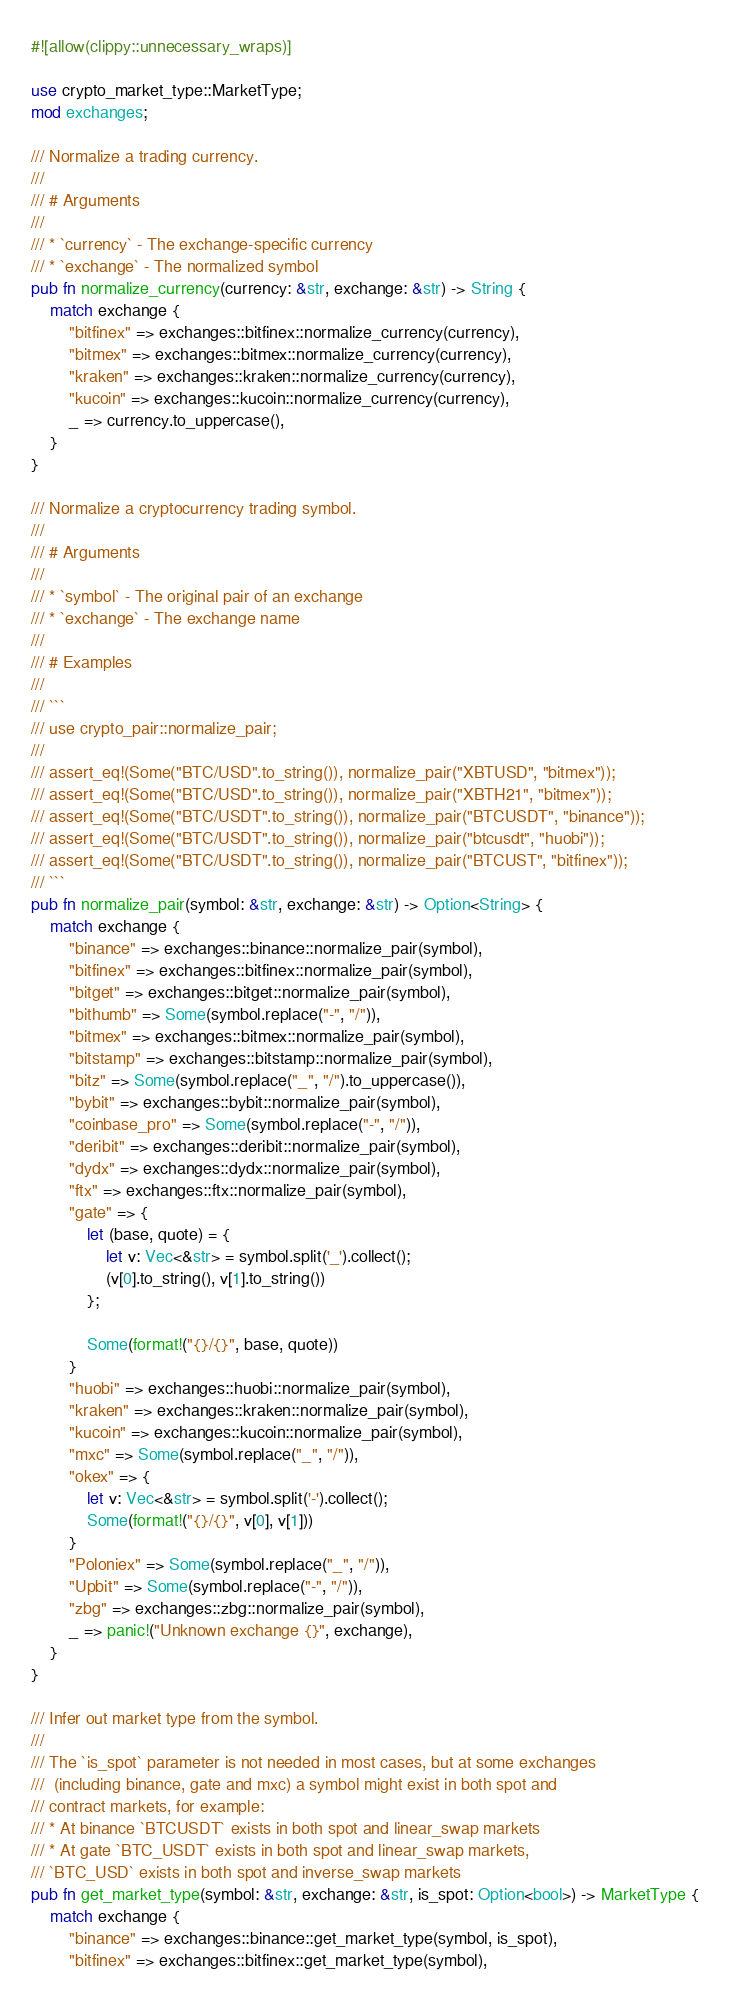<code> <loc_0><loc_0><loc_500><loc_500><_Rust_>#![allow(clippy::unnecessary_wraps)]

use crypto_market_type::MarketType;
mod exchanges;

/// Normalize a trading currency.
///
/// # Arguments
///
/// * `currency` - The exchange-specific currency
/// * `exchange` - The normalized symbol
pub fn normalize_currency(currency: &str, exchange: &str) -> String {
    match exchange {
        "bitfinex" => exchanges::bitfinex::normalize_currency(currency),
        "bitmex" => exchanges::bitmex::normalize_currency(currency),
        "kraken" => exchanges::kraken::normalize_currency(currency),
        "kucoin" => exchanges::kucoin::normalize_currency(currency),
        _ => currency.to_uppercase(),
    }
}

/// Normalize a cryptocurrency trading symbol.
///
/// # Arguments
///
/// * `symbol` - The original pair of an exchange
/// * `exchange` - The exchange name
///
/// # Examples
///
/// ```
/// use crypto_pair::normalize_pair;
///
/// assert_eq!(Some("BTC/USD".to_string()), normalize_pair("XBTUSD", "bitmex"));
/// assert_eq!(Some("BTC/USD".to_string()), normalize_pair("XBTH21", "bitmex"));
/// assert_eq!(Some("BTC/USDT".to_string()), normalize_pair("BTCUSDT", "binance"));
/// assert_eq!(Some("BTC/USDT".to_string()), normalize_pair("btcusdt", "huobi"));
/// assert_eq!(Some("BTC/USDT".to_string()), normalize_pair("BTCUST", "bitfinex"));
/// ```
pub fn normalize_pair(symbol: &str, exchange: &str) -> Option<String> {
    match exchange {
        "binance" => exchanges::binance::normalize_pair(symbol),
        "bitfinex" => exchanges::bitfinex::normalize_pair(symbol),
        "bitget" => exchanges::bitget::normalize_pair(symbol),
        "bithumb" => Some(symbol.replace("-", "/")),
        "bitmex" => exchanges::bitmex::normalize_pair(symbol),
        "bitstamp" => exchanges::bitstamp::normalize_pair(symbol),
        "bitz" => Some(symbol.replace("_", "/").to_uppercase()),
        "bybit" => exchanges::bybit::normalize_pair(symbol),
        "coinbase_pro" => Some(symbol.replace("-", "/")),
        "deribit" => exchanges::deribit::normalize_pair(symbol),
        "dydx" => exchanges::dydx::normalize_pair(symbol),
        "ftx" => exchanges::ftx::normalize_pair(symbol),
        "gate" => {
            let (base, quote) = {
                let v: Vec<&str> = symbol.split('_').collect();
                (v[0].to_string(), v[1].to_string())
            };

            Some(format!("{}/{}", base, quote))
        }
        "huobi" => exchanges::huobi::normalize_pair(symbol),
        "kraken" => exchanges::kraken::normalize_pair(symbol),
        "kucoin" => exchanges::kucoin::normalize_pair(symbol),
        "mxc" => Some(symbol.replace("_", "/")),
        "okex" => {
            let v: Vec<&str> = symbol.split('-').collect();
            Some(format!("{}/{}", v[0], v[1]))
        }
        "Poloniex" => Some(symbol.replace("_", "/")),
        "Upbit" => Some(symbol.replace("-", "/")),
        "zbg" => exchanges::zbg::normalize_pair(symbol),
        _ => panic!("Unknown exchange {}", exchange),
    }
}

/// Infer out market type from the symbol.
///
/// The `is_spot` parameter is not needed in most cases, but at some exchanges
///  (including binance, gate and mxc) a symbol might exist in both spot and
/// contract markets, for example:
/// * At binance `BTCUSDT` exists in both spot and linear_swap markets
/// * At gate `BTC_USDT` exists in both spot and linear_swap markets,
/// `BTC_USD` exists in both spot and inverse_swap markets
pub fn get_market_type(symbol: &str, exchange: &str, is_spot: Option<bool>) -> MarketType {
    match exchange {
        "binance" => exchanges::binance::get_market_type(symbol, is_spot),
        "bitfinex" => exchanges::bitfinex::get_market_type(symbol),</code> 